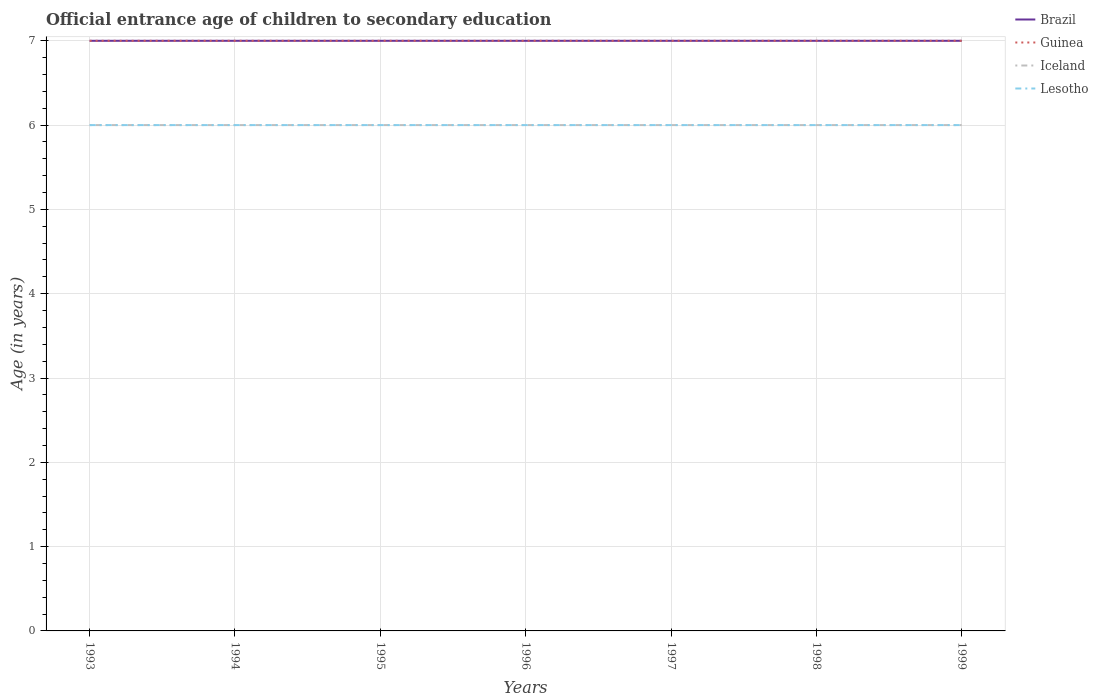Does the line corresponding to Iceland intersect with the line corresponding to Lesotho?
Offer a terse response. Yes. Is the number of lines equal to the number of legend labels?
Provide a short and direct response. Yes. Across all years, what is the maximum secondary school starting age of children in Guinea?
Provide a succinct answer. 7. In which year was the secondary school starting age of children in Brazil maximum?
Your answer should be very brief. 1993. What is the total secondary school starting age of children in Guinea in the graph?
Ensure brevity in your answer.  0. What is the difference between the highest and the lowest secondary school starting age of children in Lesotho?
Your answer should be very brief. 0. Is the secondary school starting age of children in Guinea strictly greater than the secondary school starting age of children in Lesotho over the years?
Ensure brevity in your answer.  No. How many years are there in the graph?
Your response must be concise. 7. What is the difference between two consecutive major ticks on the Y-axis?
Provide a succinct answer. 1. Does the graph contain any zero values?
Offer a very short reply. No. Does the graph contain grids?
Offer a very short reply. Yes. How many legend labels are there?
Your answer should be compact. 4. What is the title of the graph?
Provide a short and direct response. Official entrance age of children to secondary education. Does "Namibia" appear as one of the legend labels in the graph?
Offer a very short reply. No. What is the label or title of the Y-axis?
Your answer should be very brief. Age (in years). What is the Age (in years) of Iceland in 1993?
Provide a short and direct response. 6. What is the Age (in years) in Brazil in 1994?
Offer a terse response. 7. What is the Age (in years) in Lesotho in 1994?
Your answer should be very brief. 6. What is the Age (in years) in Brazil in 1995?
Your answer should be very brief. 7. What is the Age (in years) of Lesotho in 1995?
Give a very brief answer. 6. What is the Age (in years) in Brazil in 1996?
Give a very brief answer. 7. What is the Age (in years) in Iceland in 1996?
Keep it short and to the point. 6. What is the Age (in years) of Brazil in 1997?
Give a very brief answer. 7. What is the Age (in years) of Iceland in 1997?
Provide a short and direct response. 6. What is the Age (in years) of Brazil in 1998?
Provide a short and direct response. 7. What is the Age (in years) of Guinea in 1998?
Keep it short and to the point. 7. What is the Age (in years) in Iceland in 1998?
Offer a very short reply. 6. What is the Age (in years) in Lesotho in 1998?
Provide a succinct answer. 6. What is the Age (in years) in Brazil in 1999?
Give a very brief answer. 7. What is the Age (in years) of Guinea in 1999?
Your answer should be very brief. 7. What is the Age (in years) of Lesotho in 1999?
Keep it short and to the point. 6. Across all years, what is the maximum Age (in years) in Guinea?
Provide a succinct answer. 7. Across all years, what is the minimum Age (in years) of Iceland?
Offer a very short reply. 6. Across all years, what is the minimum Age (in years) of Lesotho?
Keep it short and to the point. 6. What is the total Age (in years) in Brazil in the graph?
Your response must be concise. 49. What is the total Age (in years) of Guinea in the graph?
Offer a terse response. 49. What is the total Age (in years) in Lesotho in the graph?
Provide a short and direct response. 42. What is the difference between the Age (in years) in Guinea in 1993 and that in 1994?
Your answer should be very brief. 0. What is the difference between the Age (in years) in Iceland in 1993 and that in 1994?
Make the answer very short. 0. What is the difference between the Age (in years) of Lesotho in 1993 and that in 1994?
Keep it short and to the point. 0. What is the difference between the Age (in years) of Brazil in 1993 and that in 1995?
Keep it short and to the point. 0. What is the difference between the Age (in years) in Lesotho in 1993 and that in 1995?
Keep it short and to the point. 0. What is the difference between the Age (in years) in Guinea in 1993 and that in 1996?
Offer a terse response. 0. What is the difference between the Age (in years) in Iceland in 1993 and that in 1996?
Offer a terse response. 0. What is the difference between the Age (in years) of Brazil in 1993 and that in 1997?
Your response must be concise. 0. What is the difference between the Age (in years) of Iceland in 1993 and that in 1997?
Offer a very short reply. 0. What is the difference between the Age (in years) in Lesotho in 1993 and that in 1997?
Keep it short and to the point. 0. What is the difference between the Age (in years) of Brazil in 1993 and that in 1999?
Provide a succinct answer. 0. What is the difference between the Age (in years) in Guinea in 1993 and that in 1999?
Offer a very short reply. 0. What is the difference between the Age (in years) of Lesotho in 1993 and that in 1999?
Give a very brief answer. 0. What is the difference between the Age (in years) of Guinea in 1994 and that in 1995?
Keep it short and to the point. 0. What is the difference between the Age (in years) of Guinea in 1994 and that in 1996?
Your answer should be very brief. 0. What is the difference between the Age (in years) of Brazil in 1994 and that in 1997?
Offer a terse response. 0. What is the difference between the Age (in years) of Iceland in 1994 and that in 1997?
Provide a succinct answer. 0. What is the difference between the Age (in years) of Iceland in 1994 and that in 1998?
Your answer should be compact. 0. What is the difference between the Age (in years) of Brazil in 1994 and that in 1999?
Offer a very short reply. 0. What is the difference between the Age (in years) in Guinea in 1994 and that in 1999?
Offer a very short reply. 0. What is the difference between the Age (in years) in Lesotho in 1994 and that in 1999?
Your response must be concise. 0. What is the difference between the Age (in years) of Brazil in 1995 and that in 1996?
Ensure brevity in your answer.  0. What is the difference between the Age (in years) in Guinea in 1995 and that in 1996?
Ensure brevity in your answer.  0. What is the difference between the Age (in years) of Guinea in 1995 and that in 1997?
Offer a very short reply. 0. What is the difference between the Age (in years) of Lesotho in 1995 and that in 1997?
Your answer should be very brief. 0. What is the difference between the Age (in years) of Guinea in 1995 and that in 1998?
Your response must be concise. 0. What is the difference between the Age (in years) in Iceland in 1995 and that in 1998?
Your answer should be very brief. 0. What is the difference between the Age (in years) of Lesotho in 1995 and that in 1998?
Keep it short and to the point. 0. What is the difference between the Age (in years) of Guinea in 1995 and that in 1999?
Provide a short and direct response. 0. What is the difference between the Age (in years) in Lesotho in 1995 and that in 1999?
Offer a terse response. 0. What is the difference between the Age (in years) in Brazil in 1996 and that in 1997?
Your answer should be very brief. 0. What is the difference between the Age (in years) in Guinea in 1996 and that in 1997?
Provide a short and direct response. 0. What is the difference between the Age (in years) in Iceland in 1996 and that in 1997?
Your answer should be very brief. 0. What is the difference between the Age (in years) in Guinea in 1996 and that in 1998?
Give a very brief answer. 0. What is the difference between the Age (in years) in Lesotho in 1996 and that in 1998?
Provide a short and direct response. 0. What is the difference between the Age (in years) of Brazil in 1996 and that in 1999?
Provide a succinct answer. 0. What is the difference between the Age (in years) in Guinea in 1996 and that in 1999?
Provide a succinct answer. 0. What is the difference between the Age (in years) of Iceland in 1996 and that in 1999?
Your response must be concise. 0. What is the difference between the Age (in years) in Brazil in 1997 and that in 1998?
Offer a very short reply. 0. What is the difference between the Age (in years) in Guinea in 1997 and that in 1998?
Offer a terse response. 0. What is the difference between the Age (in years) in Guinea in 1997 and that in 1999?
Offer a terse response. 0. What is the difference between the Age (in years) of Iceland in 1997 and that in 1999?
Offer a terse response. 0. What is the difference between the Age (in years) in Lesotho in 1997 and that in 1999?
Ensure brevity in your answer.  0. What is the difference between the Age (in years) in Guinea in 1998 and that in 1999?
Make the answer very short. 0. What is the difference between the Age (in years) in Iceland in 1998 and that in 1999?
Make the answer very short. 0. What is the difference between the Age (in years) of Lesotho in 1998 and that in 1999?
Your answer should be compact. 0. What is the difference between the Age (in years) of Brazil in 1993 and the Age (in years) of Guinea in 1994?
Provide a succinct answer. 0. What is the difference between the Age (in years) in Brazil in 1993 and the Age (in years) in Iceland in 1994?
Provide a short and direct response. 1. What is the difference between the Age (in years) in Brazil in 1993 and the Age (in years) in Lesotho in 1994?
Provide a short and direct response. 1. What is the difference between the Age (in years) in Guinea in 1993 and the Age (in years) in Iceland in 1994?
Give a very brief answer. 1. What is the difference between the Age (in years) in Brazil in 1993 and the Age (in years) in Iceland in 1995?
Your answer should be compact. 1. What is the difference between the Age (in years) of Brazil in 1993 and the Age (in years) of Lesotho in 1995?
Your response must be concise. 1. What is the difference between the Age (in years) in Guinea in 1993 and the Age (in years) in Iceland in 1995?
Keep it short and to the point. 1. What is the difference between the Age (in years) in Iceland in 1993 and the Age (in years) in Lesotho in 1995?
Provide a succinct answer. 0. What is the difference between the Age (in years) in Brazil in 1993 and the Age (in years) in Guinea in 1996?
Your response must be concise. 0. What is the difference between the Age (in years) of Brazil in 1993 and the Age (in years) of Iceland in 1996?
Your response must be concise. 1. What is the difference between the Age (in years) in Guinea in 1993 and the Age (in years) in Iceland in 1996?
Your answer should be very brief. 1. What is the difference between the Age (in years) in Iceland in 1993 and the Age (in years) in Lesotho in 1996?
Offer a terse response. 0. What is the difference between the Age (in years) of Brazil in 1993 and the Age (in years) of Iceland in 1997?
Ensure brevity in your answer.  1. What is the difference between the Age (in years) of Guinea in 1993 and the Age (in years) of Iceland in 1997?
Make the answer very short. 1. What is the difference between the Age (in years) of Guinea in 1993 and the Age (in years) of Lesotho in 1997?
Make the answer very short. 1. What is the difference between the Age (in years) in Iceland in 1993 and the Age (in years) in Lesotho in 1997?
Keep it short and to the point. 0. What is the difference between the Age (in years) of Brazil in 1993 and the Age (in years) of Guinea in 1998?
Make the answer very short. 0. What is the difference between the Age (in years) of Guinea in 1993 and the Age (in years) of Lesotho in 1998?
Make the answer very short. 1. What is the difference between the Age (in years) in Brazil in 1993 and the Age (in years) in Guinea in 1999?
Make the answer very short. 0. What is the difference between the Age (in years) in Brazil in 1993 and the Age (in years) in Iceland in 1999?
Keep it short and to the point. 1. What is the difference between the Age (in years) of Guinea in 1993 and the Age (in years) of Lesotho in 1999?
Ensure brevity in your answer.  1. What is the difference between the Age (in years) in Brazil in 1994 and the Age (in years) in Guinea in 1995?
Your answer should be compact. 0. What is the difference between the Age (in years) of Brazil in 1994 and the Age (in years) of Lesotho in 1995?
Provide a succinct answer. 1. What is the difference between the Age (in years) of Guinea in 1994 and the Age (in years) of Lesotho in 1995?
Your response must be concise. 1. What is the difference between the Age (in years) in Brazil in 1994 and the Age (in years) in Lesotho in 1996?
Give a very brief answer. 1. What is the difference between the Age (in years) in Guinea in 1994 and the Age (in years) in Iceland in 1996?
Provide a succinct answer. 1. What is the difference between the Age (in years) in Iceland in 1994 and the Age (in years) in Lesotho in 1996?
Provide a short and direct response. 0. What is the difference between the Age (in years) of Brazil in 1994 and the Age (in years) of Lesotho in 1997?
Give a very brief answer. 1. What is the difference between the Age (in years) of Guinea in 1994 and the Age (in years) of Lesotho in 1997?
Give a very brief answer. 1. What is the difference between the Age (in years) in Iceland in 1994 and the Age (in years) in Lesotho in 1997?
Offer a very short reply. 0. What is the difference between the Age (in years) in Brazil in 1994 and the Age (in years) in Guinea in 1998?
Make the answer very short. 0. What is the difference between the Age (in years) of Brazil in 1994 and the Age (in years) of Lesotho in 1998?
Make the answer very short. 1. What is the difference between the Age (in years) of Guinea in 1994 and the Age (in years) of Iceland in 1998?
Your response must be concise. 1. What is the difference between the Age (in years) of Brazil in 1994 and the Age (in years) of Guinea in 1999?
Offer a very short reply. 0. What is the difference between the Age (in years) of Brazil in 1994 and the Age (in years) of Lesotho in 1999?
Keep it short and to the point. 1. What is the difference between the Age (in years) of Brazil in 1995 and the Age (in years) of Iceland in 1996?
Ensure brevity in your answer.  1. What is the difference between the Age (in years) in Guinea in 1995 and the Age (in years) in Iceland in 1996?
Your answer should be very brief. 1. What is the difference between the Age (in years) of Guinea in 1995 and the Age (in years) of Lesotho in 1996?
Your response must be concise. 1. What is the difference between the Age (in years) of Iceland in 1995 and the Age (in years) of Lesotho in 1996?
Ensure brevity in your answer.  0. What is the difference between the Age (in years) in Brazil in 1995 and the Age (in years) in Iceland in 1997?
Keep it short and to the point. 1. What is the difference between the Age (in years) in Guinea in 1995 and the Age (in years) in Iceland in 1997?
Provide a short and direct response. 1. What is the difference between the Age (in years) of Guinea in 1995 and the Age (in years) of Lesotho in 1997?
Offer a very short reply. 1. What is the difference between the Age (in years) in Brazil in 1995 and the Age (in years) in Iceland in 1998?
Your answer should be very brief. 1. What is the difference between the Age (in years) of Guinea in 1995 and the Age (in years) of Iceland in 1998?
Make the answer very short. 1. What is the difference between the Age (in years) of Guinea in 1995 and the Age (in years) of Lesotho in 1998?
Provide a succinct answer. 1. What is the difference between the Age (in years) of Brazil in 1995 and the Age (in years) of Guinea in 1999?
Your response must be concise. 0. What is the difference between the Age (in years) of Brazil in 1995 and the Age (in years) of Lesotho in 1999?
Your response must be concise. 1. What is the difference between the Age (in years) in Guinea in 1995 and the Age (in years) in Iceland in 1999?
Provide a succinct answer. 1. What is the difference between the Age (in years) in Brazil in 1996 and the Age (in years) in Iceland in 1997?
Ensure brevity in your answer.  1. What is the difference between the Age (in years) in Guinea in 1996 and the Age (in years) in Iceland in 1997?
Ensure brevity in your answer.  1. What is the difference between the Age (in years) in Brazil in 1996 and the Age (in years) in Lesotho in 1998?
Provide a short and direct response. 1. What is the difference between the Age (in years) in Iceland in 1996 and the Age (in years) in Lesotho in 1998?
Your response must be concise. 0. What is the difference between the Age (in years) in Brazil in 1996 and the Age (in years) in Guinea in 1999?
Your answer should be compact. 0. What is the difference between the Age (in years) in Brazil in 1996 and the Age (in years) in Lesotho in 1999?
Your response must be concise. 1. What is the difference between the Age (in years) in Guinea in 1996 and the Age (in years) in Lesotho in 1999?
Keep it short and to the point. 1. What is the difference between the Age (in years) in Iceland in 1996 and the Age (in years) in Lesotho in 1999?
Your response must be concise. 0. What is the difference between the Age (in years) in Brazil in 1997 and the Age (in years) in Iceland in 1998?
Ensure brevity in your answer.  1. What is the difference between the Age (in years) in Brazil in 1997 and the Age (in years) in Lesotho in 1998?
Your response must be concise. 1. What is the difference between the Age (in years) in Guinea in 1997 and the Age (in years) in Lesotho in 1998?
Offer a very short reply. 1. What is the difference between the Age (in years) of Brazil in 1997 and the Age (in years) of Guinea in 1999?
Offer a very short reply. 0. What is the difference between the Age (in years) in Guinea in 1997 and the Age (in years) in Iceland in 1999?
Offer a terse response. 1. What is the difference between the Age (in years) of Guinea in 1997 and the Age (in years) of Lesotho in 1999?
Your answer should be compact. 1. What is the difference between the Age (in years) in Iceland in 1997 and the Age (in years) in Lesotho in 1999?
Provide a short and direct response. 0. What is the difference between the Age (in years) in Guinea in 1998 and the Age (in years) in Iceland in 1999?
Provide a succinct answer. 1. What is the average Age (in years) of Brazil per year?
Ensure brevity in your answer.  7. What is the average Age (in years) of Guinea per year?
Make the answer very short. 7. In the year 1993, what is the difference between the Age (in years) in Brazil and Age (in years) in Iceland?
Your response must be concise. 1. In the year 1993, what is the difference between the Age (in years) of Guinea and Age (in years) of Iceland?
Ensure brevity in your answer.  1. In the year 1993, what is the difference between the Age (in years) in Guinea and Age (in years) in Lesotho?
Your answer should be very brief. 1. In the year 1993, what is the difference between the Age (in years) in Iceland and Age (in years) in Lesotho?
Offer a very short reply. 0. In the year 1994, what is the difference between the Age (in years) of Brazil and Age (in years) of Guinea?
Provide a succinct answer. 0. In the year 1994, what is the difference between the Age (in years) in Brazil and Age (in years) in Lesotho?
Provide a short and direct response. 1. In the year 1994, what is the difference between the Age (in years) of Guinea and Age (in years) of Lesotho?
Offer a terse response. 1. In the year 1995, what is the difference between the Age (in years) of Brazil and Age (in years) of Iceland?
Your response must be concise. 1. In the year 1995, what is the difference between the Age (in years) in Guinea and Age (in years) in Iceland?
Offer a terse response. 1. In the year 1996, what is the difference between the Age (in years) in Brazil and Age (in years) in Iceland?
Your answer should be compact. 1. In the year 1996, what is the difference between the Age (in years) of Brazil and Age (in years) of Lesotho?
Keep it short and to the point. 1. In the year 1996, what is the difference between the Age (in years) of Iceland and Age (in years) of Lesotho?
Give a very brief answer. 0. In the year 1997, what is the difference between the Age (in years) in Brazil and Age (in years) in Guinea?
Make the answer very short. 0. In the year 1997, what is the difference between the Age (in years) of Guinea and Age (in years) of Iceland?
Give a very brief answer. 1. In the year 1997, what is the difference between the Age (in years) in Guinea and Age (in years) in Lesotho?
Make the answer very short. 1. In the year 1998, what is the difference between the Age (in years) of Brazil and Age (in years) of Iceland?
Provide a short and direct response. 1. In the year 1998, what is the difference between the Age (in years) in Guinea and Age (in years) in Iceland?
Offer a terse response. 1. In the year 1998, what is the difference between the Age (in years) of Iceland and Age (in years) of Lesotho?
Provide a succinct answer. 0. In the year 1999, what is the difference between the Age (in years) of Brazil and Age (in years) of Guinea?
Ensure brevity in your answer.  0. In the year 1999, what is the difference between the Age (in years) in Brazil and Age (in years) in Lesotho?
Keep it short and to the point. 1. In the year 1999, what is the difference between the Age (in years) in Guinea and Age (in years) in Lesotho?
Ensure brevity in your answer.  1. What is the ratio of the Age (in years) of Brazil in 1993 to that in 1994?
Ensure brevity in your answer.  1. What is the ratio of the Age (in years) in Iceland in 1993 to that in 1994?
Give a very brief answer. 1. What is the ratio of the Age (in years) in Guinea in 1993 to that in 1995?
Your answer should be very brief. 1. What is the ratio of the Age (in years) of Iceland in 1993 to that in 1995?
Keep it short and to the point. 1. What is the ratio of the Age (in years) in Guinea in 1993 to that in 1996?
Give a very brief answer. 1. What is the ratio of the Age (in years) in Brazil in 1993 to that in 1997?
Make the answer very short. 1. What is the ratio of the Age (in years) of Guinea in 1993 to that in 1997?
Your answer should be compact. 1. What is the ratio of the Age (in years) of Brazil in 1993 to that in 1998?
Give a very brief answer. 1. What is the ratio of the Age (in years) in Guinea in 1993 to that in 1998?
Offer a terse response. 1. What is the ratio of the Age (in years) of Iceland in 1993 to that in 1998?
Your response must be concise. 1. What is the ratio of the Age (in years) of Lesotho in 1993 to that in 1998?
Your response must be concise. 1. What is the ratio of the Age (in years) of Guinea in 1993 to that in 1999?
Keep it short and to the point. 1. What is the ratio of the Age (in years) in Iceland in 1993 to that in 1999?
Ensure brevity in your answer.  1. What is the ratio of the Age (in years) in Brazil in 1994 to that in 1996?
Your answer should be very brief. 1. What is the ratio of the Age (in years) of Guinea in 1994 to that in 1996?
Offer a terse response. 1. What is the ratio of the Age (in years) in Iceland in 1994 to that in 1996?
Offer a very short reply. 1. What is the ratio of the Age (in years) of Brazil in 1994 to that in 1997?
Your answer should be very brief. 1. What is the ratio of the Age (in years) of Guinea in 1994 to that in 1997?
Give a very brief answer. 1. What is the ratio of the Age (in years) of Lesotho in 1994 to that in 1997?
Your answer should be compact. 1. What is the ratio of the Age (in years) of Lesotho in 1994 to that in 1998?
Give a very brief answer. 1. What is the ratio of the Age (in years) of Brazil in 1994 to that in 1999?
Your answer should be very brief. 1. What is the ratio of the Age (in years) in Guinea in 1994 to that in 1999?
Your response must be concise. 1. What is the ratio of the Age (in years) of Brazil in 1995 to that in 1996?
Provide a short and direct response. 1. What is the ratio of the Age (in years) of Brazil in 1995 to that in 1997?
Provide a short and direct response. 1. What is the ratio of the Age (in years) of Guinea in 1995 to that in 1997?
Provide a succinct answer. 1. What is the ratio of the Age (in years) in Guinea in 1995 to that in 1998?
Ensure brevity in your answer.  1. What is the ratio of the Age (in years) of Iceland in 1995 to that in 1998?
Give a very brief answer. 1. What is the ratio of the Age (in years) of Brazil in 1995 to that in 1999?
Your answer should be compact. 1. What is the ratio of the Age (in years) in Guinea in 1995 to that in 1999?
Provide a short and direct response. 1. What is the ratio of the Age (in years) of Iceland in 1996 to that in 1997?
Your answer should be compact. 1. What is the ratio of the Age (in years) in Lesotho in 1996 to that in 1997?
Keep it short and to the point. 1. What is the ratio of the Age (in years) of Guinea in 1996 to that in 1998?
Ensure brevity in your answer.  1. What is the ratio of the Age (in years) of Iceland in 1996 to that in 1998?
Your answer should be compact. 1. What is the ratio of the Age (in years) in Guinea in 1996 to that in 1999?
Give a very brief answer. 1. What is the ratio of the Age (in years) of Iceland in 1996 to that in 1999?
Provide a short and direct response. 1. What is the ratio of the Age (in years) of Lesotho in 1996 to that in 1999?
Your answer should be compact. 1. What is the ratio of the Age (in years) in Brazil in 1997 to that in 1998?
Provide a succinct answer. 1. What is the ratio of the Age (in years) in Guinea in 1997 to that in 1998?
Keep it short and to the point. 1. What is the ratio of the Age (in years) of Iceland in 1997 to that in 1998?
Your response must be concise. 1. What is the ratio of the Age (in years) of Iceland in 1997 to that in 1999?
Provide a succinct answer. 1. What is the ratio of the Age (in years) in Guinea in 1998 to that in 1999?
Your answer should be very brief. 1. What is the difference between the highest and the second highest Age (in years) in Guinea?
Your answer should be very brief. 0. What is the difference between the highest and the second highest Age (in years) in Lesotho?
Give a very brief answer. 0. What is the difference between the highest and the lowest Age (in years) of Iceland?
Give a very brief answer. 0. 